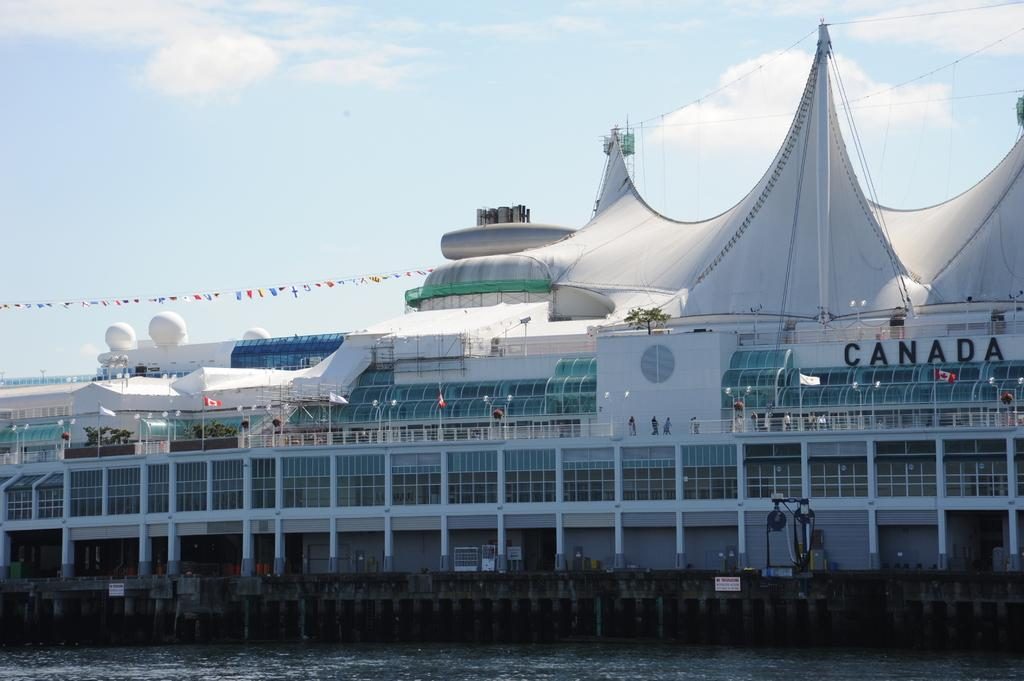What is the main subject of the image? The main subject of the image is a ship. Where is the ship located? The ship is on the water. Are there any people on the ship? Yes, there are people in the ship. What can be seen in the background of the image? There are clouds and the sky visible in the background of the image. What type of trail can be seen on the thumb of the person in the image? There is no person or thumb visible in the image; it features a ship on the water with clouds and the sky in the background. 